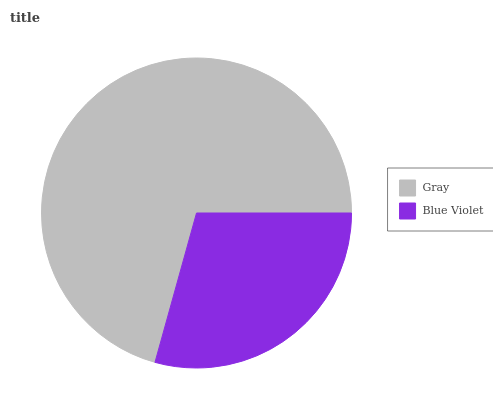Is Blue Violet the minimum?
Answer yes or no. Yes. Is Gray the maximum?
Answer yes or no. Yes. Is Blue Violet the maximum?
Answer yes or no. No. Is Gray greater than Blue Violet?
Answer yes or no. Yes. Is Blue Violet less than Gray?
Answer yes or no. Yes. Is Blue Violet greater than Gray?
Answer yes or no. No. Is Gray less than Blue Violet?
Answer yes or no. No. Is Gray the high median?
Answer yes or no. Yes. Is Blue Violet the low median?
Answer yes or no. Yes. Is Blue Violet the high median?
Answer yes or no. No. Is Gray the low median?
Answer yes or no. No. 